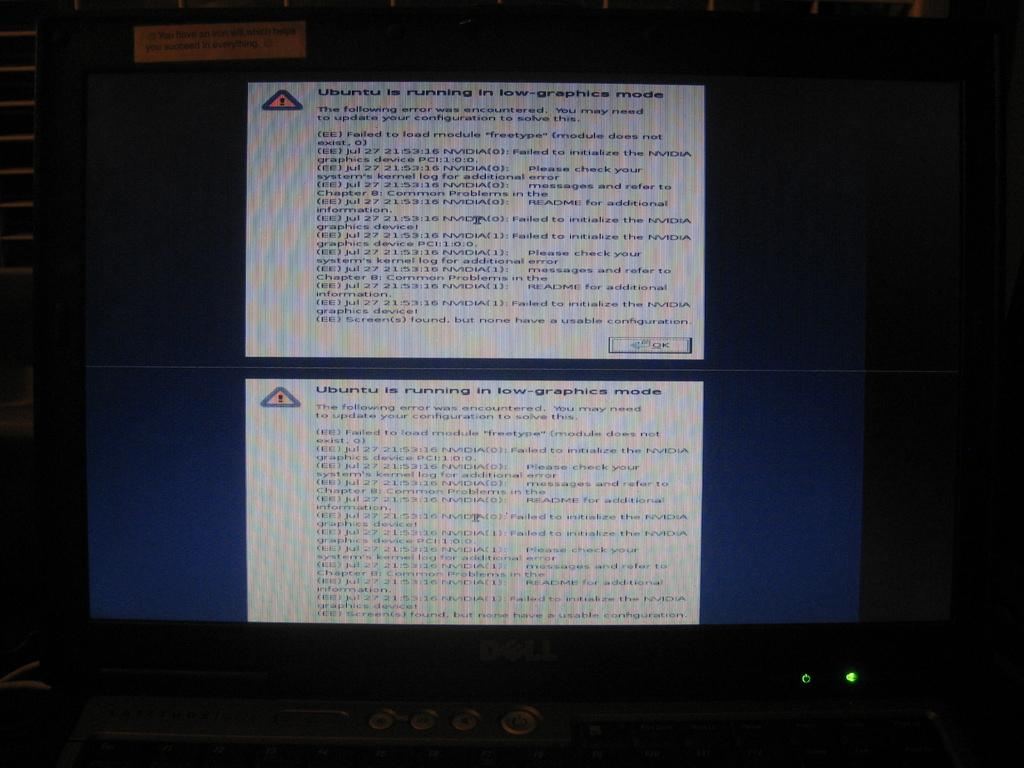<image>
Create a compact narrative representing the image presented. Dell computer screen showing that Ubuntu is running on low graphics. 